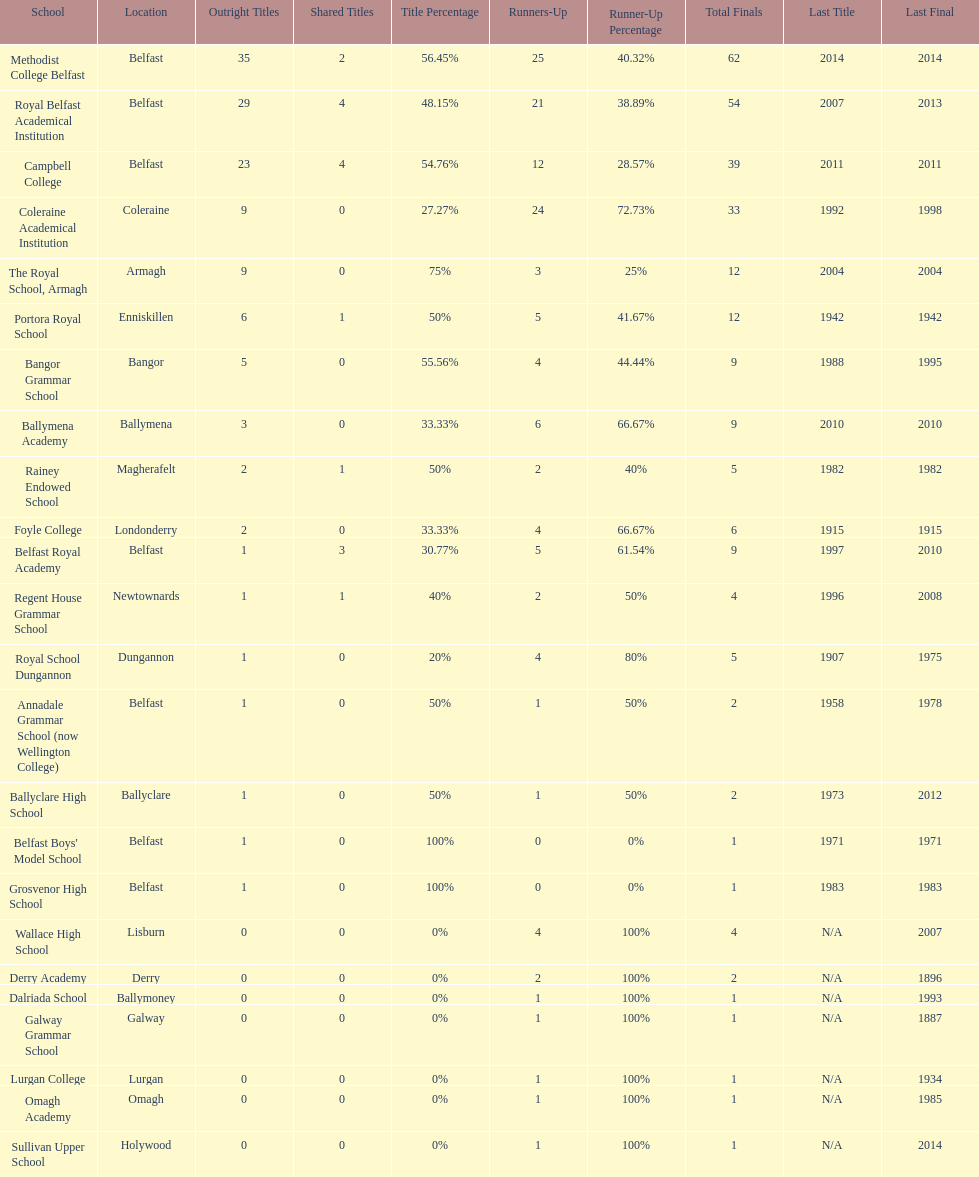What is the difference in runners-up from coleraine academical institution and royal school dungannon? 20. 